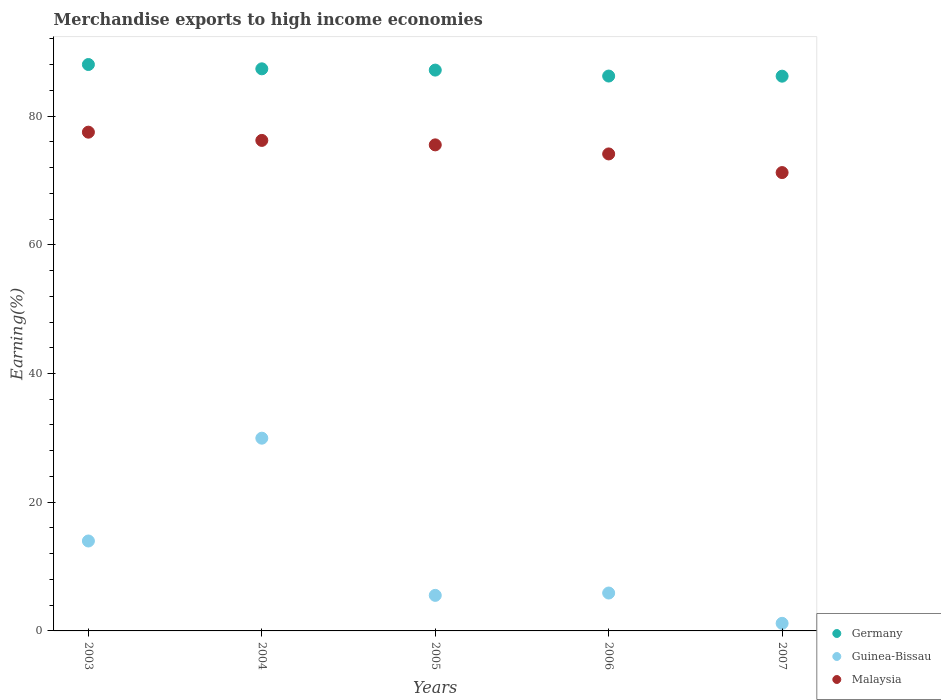How many different coloured dotlines are there?
Ensure brevity in your answer.  3. What is the percentage of amount earned from merchandise exports in Germany in 2004?
Make the answer very short. 87.34. Across all years, what is the maximum percentage of amount earned from merchandise exports in Malaysia?
Your answer should be compact. 77.5. Across all years, what is the minimum percentage of amount earned from merchandise exports in Guinea-Bissau?
Ensure brevity in your answer.  1.18. What is the total percentage of amount earned from merchandise exports in Malaysia in the graph?
Make the answer very short. 374.57. What is the difference between the percentage of amount earned from merchandise exports in Germany in 2005 and that in 2007?
Give a very brief answer. 0.95. What is the difference between the percentage of amount earned from merchandise exports in Guinea-Bissau in 2006 and the percentage of amount earned from merchandise exports in Germany in 2007?
Your answer should be very brief. -80.31. What is the average percentage of amount earned from merchandise exports in Malaysia per year?
Ensure brevity in your answer.  74.91. In the year 2007, what is the difference between the percentage of amount earned from merchandise exports in Germany and percentage of amount earned from merchandise exports in Guinea-Bissau?
Provide a short and direct response. 85.02. In how many years, is the percentage of amount earned from merchandise exports in Germany greater than 8 %?
Your answer should be compact. 5. What is the ratio of the percentage of amount earned from merchandise exports in Guinea-Bissau in 2004 to that in 2005?
Your answer should be compact. 5.42. Is the percentage of amount earned from merchandise exports in Malaysia in 2003 less than that in 2005?
Ensure brevity in your answer.  No. What is the difference between the highest and the second highest percentage of amount earned from merchandise exports in Germany?
Provide a succinct answer. 0.67. What is the difference between the highest and the lowest percentage of amount earned from merchandise exports in Guinea-Bissau?
Provide a short and direct response. 28.77. In how many years, is the percentage of amount earned from merchandise exports in Malaysia greater than the average percentage of amount earned from merchandise exports in Malaysia taken over all years?
Offer a very short reply. 3. How many dotlines are there?
Keep it short and to the point. 3. Are the values on the major ticks of Y-axis written in scientific E-notation?
Give a very brief answer. No. Where does the legend appear in the graph?
Provide a short and direct response. Bottom right. How are the legend labels stacked?
Keep it short and to the point. Vertical. What is the title of the graph?
Keep it short and to the point. Merchandise exports to high income economies. What is the label or title of the Y-axis?
Keep it short and to the point. Earning(%). What is the Earning(%) in Germany in 2003?
Offer a very short reply. 88.01. What is the Earning(%) of Guinea-Bissau in 2003?
Your answer should be very brief. 13.97. What is the Earning(%) of Malaysia in 2003?
Your response must be concise. 77.5. What is the Earning(%) in Germany in 2004?
Make the answer very short. 87.34. What is the Earning(%) of Guinea-Bissau in 2004?
Give a very brief answer. 29.95. What is the Earning(%) in Malaysia in 2004?
Provide a short and direct response. 76.22. What is the Earning(%) of Germany in 2005?
Your answer should be compact. 87.14. What is the Earning(%) in Guinea-Bissau in 2005?
Provide a short and direct response. 5.52. What is the Earning(%) of Malaysia in 2005?
Your answer should be very brief. 75.52. What is the Earning(%) in Germany in 2006?
Your response must be concise. 86.22. What is the Earning(%) of Guinea-Bissau in 2006?
Your answer should be compact. 5.89. What is the Earning(%) of Malaysia in 2006?
Keep it short and to the point. 74.11. What is the Earning(%) of Germany in 2007?
Give a very brief answer. 86.2. What is the Earning(%) of Guinea-Bissau in 2007?
Provide a short and direct response. 1.18. What is the Earning(%) in Malaysia in 2007?
Offer a terse response. 71.22. Across all years, what is the maximum Earning(%) of Germany?
Keep it short and to the point. 88.01. Across all years, what is the maximum Earning(%) of Guinea-Bissau?
Your answer should be compact. 29.95. Across all years, what is the maximum Earning(%) in Malaysia?
Provide a short and direct response. 77.5. Across all years, what is the minimum Earning(%) in Germany?
Make the answer very short. 86.2. Across all years, what is the minimum Earning(%) of Guinea-Bissau?
Give a very brief answer. 1.18. Across all years, what is the minimum Earning(%) of Malaysia?
Keep it short and to the point. 71.22. What is the total Earning(%) in Germany in the graph?
Provide a short and direct response. 434.9. What is the total Earning(%) in Guinea-Bissau in the graph?
Your response must be concise. 56.51. What is the total Earning(%) in Malaysia in the graph?
Provide a succinct answer. 374.57. What is the difference between the Earning(%) of Germany in 2003 and that in 2004?
Give a very brief answer. 0.67. What is the difference between the Earning(%) of Guinea-Bissau in 2003 and that in 2004?
Offer a terse response. -15.97. What is the difference between the Earning(%) of Malaysia in 2003 and that in 2004?
Ensure brevity in your answer.  1.28. What is the difference between the Earning(%) in Germany in 2003 and that in 2005?
Give a very brief answer. 0.87. What is the difference between the Earning(%) of Guinea-Bissau in 2003 and that in 2005?
Keep it short and to the point. 8.45. What is the difference between the Earning(%) in Malaysia in 2003 and that in 2005?
Offer a very short reply. 1.97. What is the difference between the Earning(%) in Germany in 2003 and that in 2006?
Your response must be concise. 1.79. What is the difference between the Earning(%) in Guinea-Bissau in 2003 and that in 2006?
Keep it short and to the point. 8.09. What is the difference between the Earning(%) of Malaysia in 2003 and that in 2006?
Keep it short and to the point. 3.38. What is the difference between the Earning(%) of Germany in 2003 and that in 2007?
Your answer should be compact. 1.81. What is the difference between the Earning(%) in Guinea-Bissau in 2003 and that in 2007?
Provide a short and direct response. 12.8. What is the difference between the Earning(%) in Malaysia in 2003 and that in 2007?
Ensure brevity in your answer.  6.28. What is the difference between the Earning(%) in Germany in 2004 and that in 2005?
Your answer should be compact. 0.2. What is the difference between the Earning(%) of Guinea-Bissau in 2004 and that in 2005?
Give a very brief answer. 24.42. What is the difference between the Earning(%) in Malaysia in 2004 and that in 2005?
Your answer should be very brief. 0.69. What is the difference between the Earning(%) in Germany in 2004 and that in 2006?
Offer a terse response. 1.12. What is the difference between the Earning(%) of Guinea-Bissau in 2004 and that in 2006?
Your response must be concise. 24.06. What is the difference between the Earning(%) of Malaysia in 2004 and that in 2006?
Provide a succinct answer. 2.1. What is the difference between the Earning(%) of Germany in 2004 and that in 2007?
Your answer should be compact. 1.14. What is the difference between the Earning(%) in Guinea-Bissau in 2004 and that in 2007?
Ensure brevity in your answer.  28.77. What is the difference between the Earning(%) in Malaysia in 2004 and that in 2007?
Your response must be concise. 5. What is the difference between the Earning(%) in Germany in 2005 and that in 2006?
Provide a short and direct response. 0.93. What is the difference between the Earning(%) of Guinea-Bissau in 2005 and that in 2006?
Ensure brevity in your answer.  -0.37. What is the difference between the Earning(%) of Malaysia in 2005 and that in 2006?
Offer a terse response. 1.41. What is the difference between the Earning(%) of Germany in 2005 and that in 2007?
Your answer should be very brief. 0.95. What is the difference between the Earning(%) in Guinea-Bissau in 2005 and that in 2007?
Offer a very short reply. 4.35. What is the difference between the Earning(%) of Malaysia in 2005 and that in 2007?
Keep it short and to the point. 4.3. What is the difference between the Earning(%) of Germany in 2006 and that in 2007?
Offer a terse response. 0.02. What is the difference between the Earning(%) in Guinea-Bissau in 2006 and that in 2007?
Your answer should be very brief. 4.71. What is the difference between the Earning(%) of Malaysia in 2006 and that in 2007?
Your response must be concise. 2.9. What is the difference between the Earning(%) of Germany in 2003 and the Earning(%) of Guinea-Bissau in 2004?
Your response must be concise. 58.06. What is the difference between the Earning(%) of Germany in 2003 and the Earning(%) of Malaysia in 2004?
Give a very brief answer. 11.79. What is the difference between the Earning(%) in Guinea-Bissau in 2003 and the Earning(%) in Malaysia in 2004?
Your response must be concise. -62.24. What is the difference between the Earning(%) of Germany in 2003 and the Earning(%) of Guinea-Bissau in 2005?
Your answer should be very brief. 82.48. What is the difference between the Earning(%) of Germany in 2003 and the Earning(%) of Malaysia in 2005?
Ensure brevity in your answer.  12.49. What is the difference between the Earning(%) in Guinea-Bissau in 2003 and the Earning(%) in Malaysia in 2005?
Keep it short and to the point. -61.55. What is the difference between the Earning(%) of Germany in 2003 and the Earning(%) of Guinea-Bissau in 2006?
Your response must be concise. 82.12. What is the difference between the Earning(%) in Germany in 2003 and the Earning(%) in Malaysia in 2006?
Provide a short and direct response. 13.89. What is the difference between the Earning(%) of Guinea-Bissau in 2003 and the Earning(%) of Malaysia in 2006?
Your answer should be compact. -60.14. What is the difference between the Earning(%) of Germany in 2003 and the Earning(%) of Guinea-Bissau in 2007?
Give a very brief answer. 86.83. What is the difference between the Earning(%) in Germany in 2003 and the Earning(%) in Malaysia in 2007?
Ensure brevity in your answer.  16.79. What is the difference between the Earning(%) in Guinea-Bissau in 2003 and the Earning(%) in Malaysia in 2007?
Make the answer very short. -57.24. What is the difference between the Earning(%) of Germany in 2004 and the Earning(%) of Guinea-Bissau in 2005?
Your answer should be compact. 81.82. What is the difference between the Earning(%) in Germany in 2004 and the Earning(%) in Malaysia in 2005?
Make the answer very short. 11.82. What is the difference between the Earning(%) in Guinea-Bissau in 2004 and the Earning(%) in Malaysia in 2005?
Provide a short and direct response. -45.58. What is the difference between the Earning(%) of Germany in 2004 and the Earning(%) of Guinea-Bissau in 2006?
Provide a short and direct response. 81.45. What is the difference between the Earning(%) of Germany in 2004 and the Earning(%) of Malaysia in 2006?
Your answer should be compact. 13.22. What is the difference between the Earning(%) of Guinea-Bissau in 2004 and the Earning(%) of Malaysia in 2006?
Your answer should be compact. -44.17. What is the difference between the Earning(%) of Germany in 2004 and the Earning(%) of Guinea-Bissau in 2007?
Provide a short and direct response. 86.16. What is the difference between the Earning(%) in Germany in 2004 and the Earning(%) in Malaysia in 2007?
Offer a terse response. 16.12. What is the difference between the Earning(%) of Guinea-Bissau in 2004 and the Earning(%) of Malaysia in 2007?
Provide a short and direct response. -41.27. What is the difference between the Earning(%) of Germany in 2005 and the Earning(%) of Guinea-Bissau in 2006?
Your answer should be compact. 81.25. What is the difference between the Earning(%) of Germany in 2005 and the Earning(%) of Malaysia in 2006?
Make the answer very short. 13.03. What is the difference between the Earning(%) in Guinea-Bissau in 2005 and the Earning(%) in Malaysia in 2006?
Your answer should be very brief. -68.59. What is the difference between the Earning(%) of Germany in 2005 and the Earning(%) of Guinea-Bissau in 2007?
Ensure brevity in your answer.  85.96. What is the difference between the Earning(%) in Germany in 2005 and the Earning(%) in Malaysia in 2007?
Offer a very short reply. 15.92. What is the difference between the Earning(%) of Guinea-Bissau in 2005 and the Earning(%) of Malaysia in 2007?
Your response must be concise. -65.69. What is the difference between the Earning(%) of Germany in 2006 and the Earning(%) of Guinea-Bissau in 2007?
Offer a very short reply. 85.04. What is the difference between the Earning(%) of Germany in 2006 and the Earning(%) of Malaysia in 2007?
Keep it short and to the point. 15. What is the difference between the Earning(%) in Guinea-Bissau in 2006 and the Earning(%) in Malaysia in 2007?
Offer a very short reply. -65.33. What is the average Earning(%) of Germany per year?
Provide a succinct answer. 86.98. What is the average Earning(%) of Guinea-Bissau per year?
Offer a very short reply. 11.3. What is the average Earning(%) of Malaysia per year?
Ensure brevity in your answer.  74.91. In the year 2003, what is the difference between the Earning(%) of Germany and Earning(%) of Guinea-Bissau?
Offer a terse response. 74.03. In the year 2003, what is the difference between the Earning(%) of Germany and Earning(%) of Malaysia?
Give a very brief answer. 10.51. In the year 2003, what is the difference between the Earning(%) of Guinea-Bissau and Earning(%) of Malaysia?
Your answer should be very brief. -63.52. In the year 2004, what is the difference between the Earning(%) of Germany and Earning(%) of Guinea-Bissau?
Ensure brevity in your answer.  57.39. In the year 2004, what is the difference between the Earning(%) in Germany and Earning(%) in Malaysia?
Your answer should be compact. 11.12. In the year 2004, what is the difference between the Earning(%) in Guinea-Bissau and Earning(%) in Malaysia?
Keep it short and to the point. -46.27. In the year 2005, what is the difference between the Earning(%) in Germany and Earning(%) in Guinea-Bissau?
Give a very brief answer. 81.62. In the year 2005, what is the difference between the Earning(%) in Germany and Earning(%) in Malaysia?
Your answer should be compact. 11.62. In the year 2005, what is the difference between the Earning(%) in Guinea-Bissau and Earning(%) in Malaysia?
Your answer should be compact. -70. In the year 2006, what is the difference between the Earning(%) of Germany and Earning(%) of Guinea-Bissau?
Give a very brief answer. 80.33. In the year 2006, what is the difference between the Earning(%) in Germany and Earning(%) in Malaysia?
Provide a succinct answer. 12.1. In the year 2006, what is the difference between the Earning(%) of Guinea-Bissau and Earning(%) of Malaysia?
Your response must be concise. -68.23. In the year 2007, what is the difference between the Earning(%) of Germany and Earning(%) of Guinea-Bissau?
Offer a terse response. 85.02. In the year 2007, what is the difference between the Earning(%) of Germany and Earning(%) of Malaysia?
Offer a terse response. 14.98. In the year 2007, what is the difference between the Earning(%) in Guinea-Bissau and Earning(%) in Malaysia?
Your answer should be compact. -70.04. What is the ratio of the Earning(%) in Germany in 2003 to that in 2004?
Provide a short and direct response. 1.01. What is the ratio of the Earning(%) of Guinea-Bissau in 2003 to that in 2004?
Your answer should be very brief. 0.47. What is the ratio of the Earning(%) in Malaysia in 2003 to that in 2004?
Make the answer very short. 1.02. What is the ratio of the Earning(%) of Germany in 2003 to that in 2005?
Ensure brevity in your answer.  1.01. What is the ratio of the Earning(%) of Guinea-Bissau in 2003 to that in 2005?
Make the answer very short. 2.53. What is the ratio of the Earning(%) in Malaysia in 2003 to that in 2005?
Your response must be concise. 1.03. What is the ratio of the Earning(%) of Germany in 2003 to that in 2006?
Provide a succinct answer. 1.02. What is the ratio of the Earning(%) of Guinea-Bissau in 2003 to that in 2006?
Your answer should be very brief. 2.37. What is the ratio of the Earning(%) of Malaysia in 2003 to that in 2006?
Make the answer very short. 1.05. What is the ratio of the Earning(%) of Guinea-Bissau in 2003 to that in 2007?
Offer a very short reply. 11.86. What is the ratio of the Earning(%) of Malaysia in 2003 to that in 2007?
Your response must be concise. 1.09. What is the ratio of the Earning(%) of Germany in 2004 to that in 2005?
Provide a succinct answer. 1. What is the ratio of the Earning(%) in Guinea-Bissau in 2004 to that in 2005?
Offer a terse response. 5.42. What is the ratio of the Earning(%) of Malaysia in 2004 to that in 2005?
Make the answer very short. 1.01. What is the ratio of the Earning(%) in Germany in 2004 to that in 2006?
Make the answer very short. 1.01. What is the ratio of the Earning(%) in Guinea-Bissau in 2004 to that in 2006?
Offer a terse response. 5.09. What is the ratio of the Earning(%) in Malaysia in 2004 to that in 2006?
Keep it short and to the point. 1.03. What is the ratio of the Earning(%) of Germany in 2004 to that in 2007?
Give a very brief answer. 1.01. What is the ratio of the Earning(%) of Guinea-Bissau in 2004 to that in 2007?
Provide a succinct answer. 25.42. What is the ratio of the Earning(%) of Malaysia in 2004 to that in 2007?
Keep it short and to the point. 1.07. What is the ratio of the Earning(%) of Germany in 2005 to that in 2006?
Ensure brevity in your answer.  1.01. What is the ratio of the Earning(%) of Guinea-Bissau in 2005 to that in 2006?
Your answer should be very brief. 0.94. What is the ratio of the Earning(%) of Guinea-Bissau in 2005 to that in 2007?
Offer a terse response. 4.69. What is the ratio of the Earning(%) of Malaysia in 2005 to that in 2007?
Your response must be concise. 1.06. What is the ratio of the Earning(%) of Guinea-Bissau in 2006 to that in 2007?
Keep it short and to the point. 5. What is the ratio of the Earning(%) in Malaysia in 2006 to that in 2007?
Provide a short and direct response. 1.04. What is the difference between the highest and the second highest Earning(%) of Germany?
Provide a short and direct response. 0.67. What is the difference between the highest and the second highest Earning(%) of Guinea-Bissau?
Offer a very short reply. 15.97. What is the difference between the highest and the second highest Earning(%) in Malaysia?
Provide a succinct answer. 1.28. What is the difference between the highest and the lowest Earning(%) of Germany?
Keep it short and to the point. 1.81. What is the difference between the highest and the lowest Earning(%) in Guinea-Bissau?
Offer a very short reply. 28.77. What is the difference between the highest and the lowest Earning(%) in Malaysia?
Give a very brief answer. 6.28. 